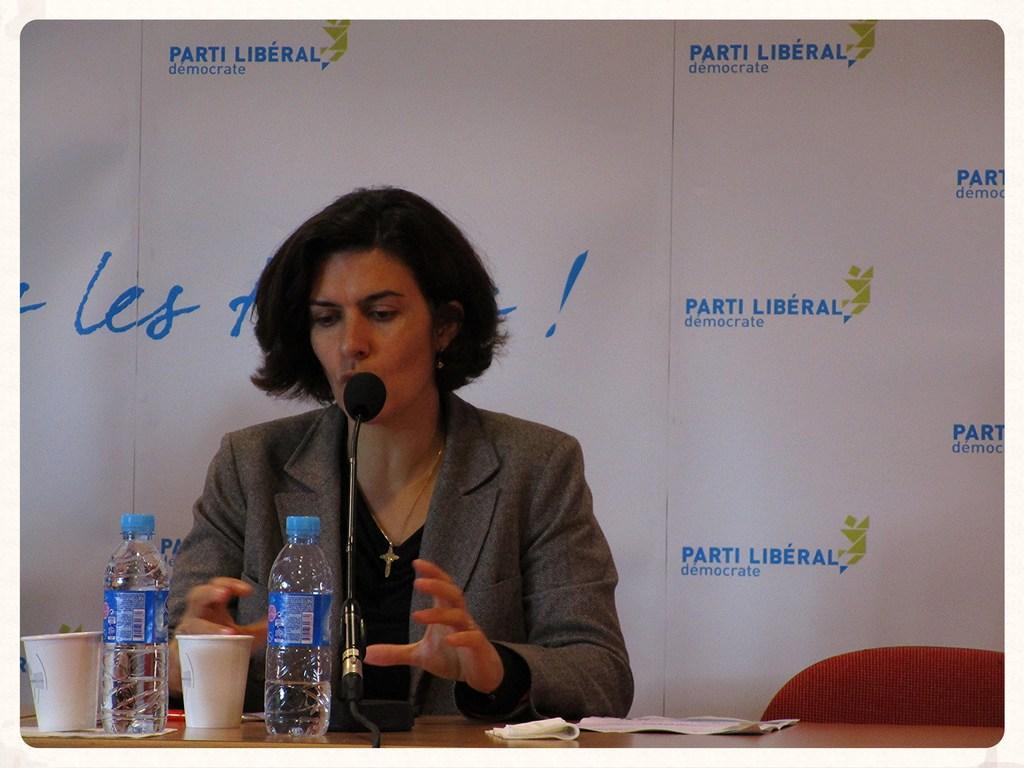In one or two sentences, can you explain what this image depicts? Here we can see a woman talking on the mike. This is a table. On the table there are bottles, glasses, and papers. There is a chair. In the background we can see a banner. 